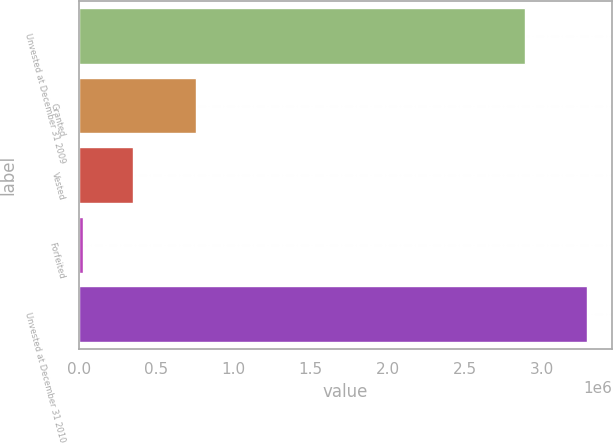<chart> <loc_0><loc_0><loc_500><loc_500><bar_chart><fcel>Unvested at December 31 2009<fcel>Granted<fcel>Vested<fcel>Forfeited<fcel>Unvested at December 31 2010<nl><fcel>2.89234e+06<fcel>755616<fcel>349348<fcel>22579<fcel>3.29027e+06<nl></chart> 